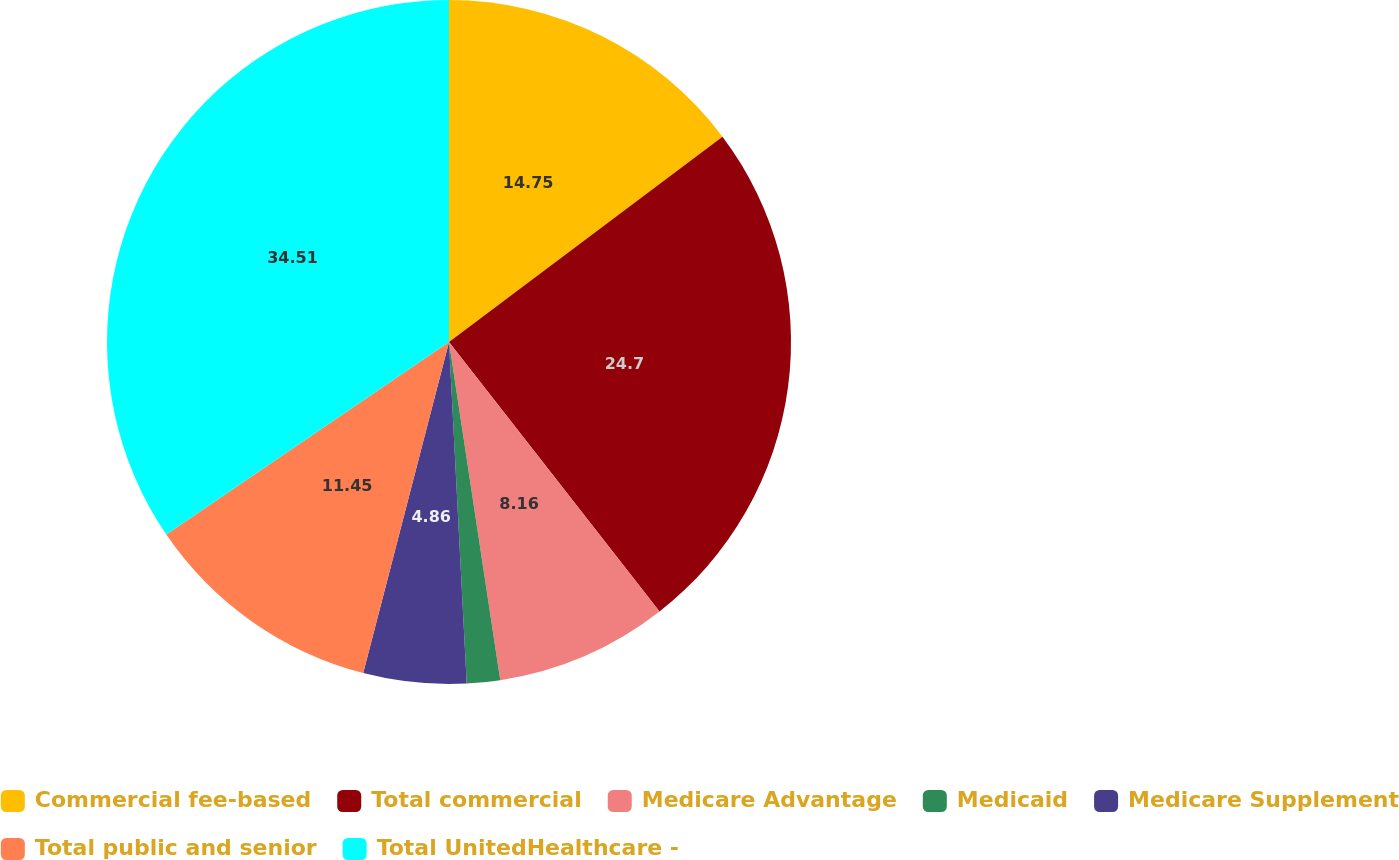Convert chart to OTSL. <chart><loc_0><loc_0><loc_500><loc_500><pie_chart><fcel>Commercial fee-based<fcel>Total commercial<fcel>Medicare Advantage<fcel>Medicaid<fcel>Medicare Supplement<fcel>Total public and senior<fcel>Total UnitedHealthcare -<nl><fcel>14.75%<fcel>24.7%<fcel>8.16%<fcel>1.57%<fcel>4.86%<fcel>11.45%<fcel>34.52%<nl></chart> 